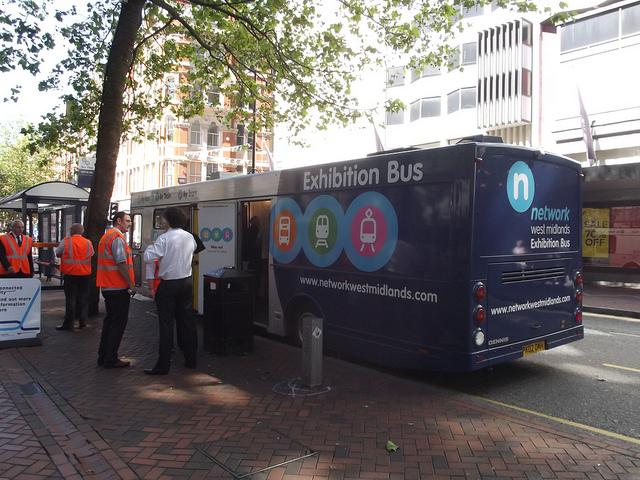What kind of bus is parked in front of the men? Please explain your reasoning. exhibition. The bus is for an exhibit. 